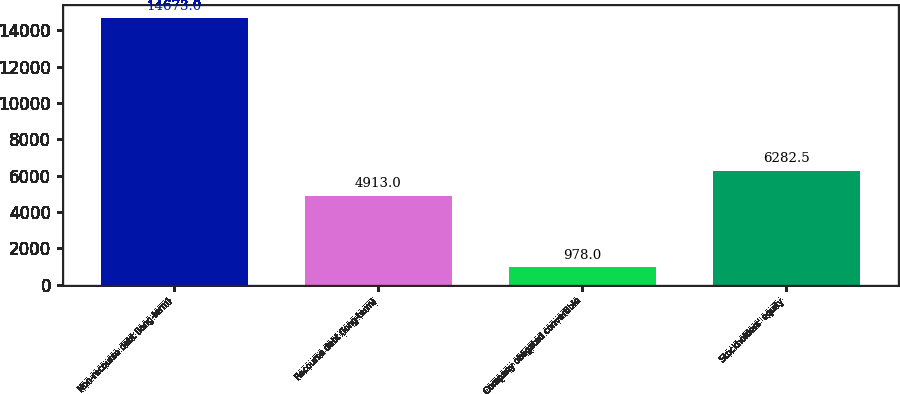Convert chart to OTSL. <chart><loc_0><loc_0><loc_500><loc_500><bar_chart><fcel>Non-recourse debt (long-term)<fcel>Recourse debt (long-term)<fcel>Company obligated convertible<fcel>Stockholders' equity<nl><fcel>14673<fcel>4913<fcel>978<fcel>6282.5<nl></chart> 